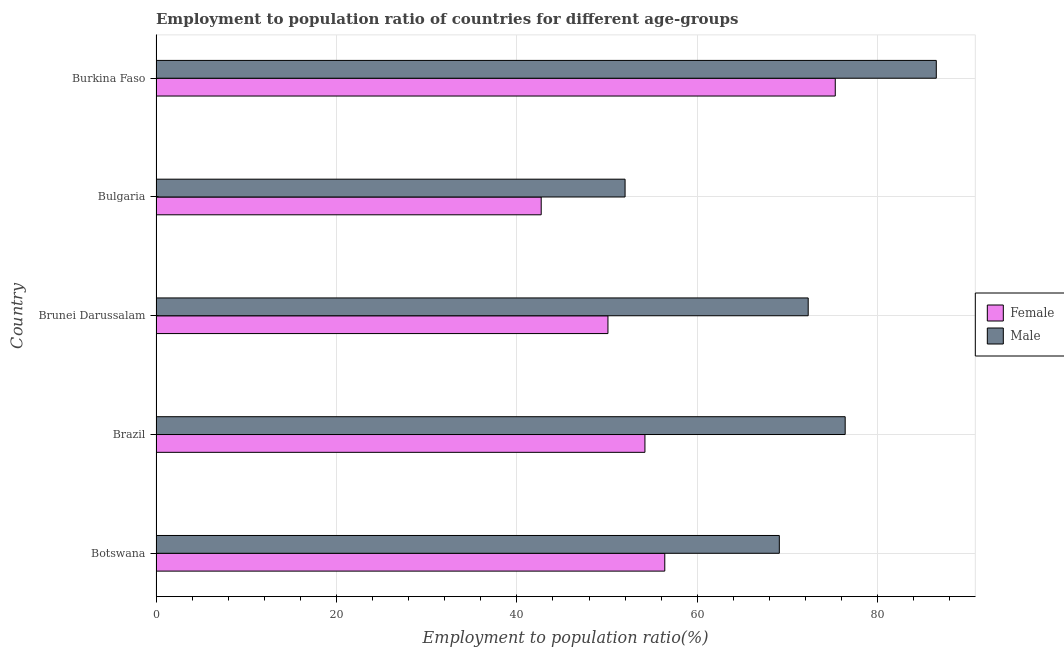How many different coloured bars are there?
Offer a terse response. 2. How many bars are there on the 3rd tick from the bottom?
Offer a very short reply. 2. What is the label of the 5th group of bars from the top?
Make the answer very short. Botswana. What is the employment to population ratio(female) in Bulgaria?
Your response must be concise. 42.7. Across all countries, what is the maximum employment to population ratio(female)?
Make the answer very short. 75.3. In which country was the employment to population ratio(female) maximum?
Offer a terse response. Burkina Faso. In which country was the employment to population ratio(male) minimum?
Provide a succinct answer. Bulgaria. What is the total employment to population ratio(female) in the graph?
Your answer should be compact. 278.7. What is the difference between the employment to population ratio(female) in Brazil and that in Burkina Faso?
Your answer should be compact. -21.1. What is the difference between the employment to population ratio(female) in Brazil and the employment to population ratio(male) in Burkina Faso?
Your answer should be very brief. -32.3. What is the average employment to population ratio(male) per country?
Your answer should be compact. 71.26. What is the difference between the employment to population ratio(male) and employment to population ratio(female) in Burkina Faso?
Your response must be concise. 11.2. What is the ratio of the employment to population ratio(male) in Brazil to that in Burkina Faso?
Your response must be concise. 0.88. Is the employment to population ratio(female) in Botswana less than that in Bulgaria?
Your answer should be compact. No. Is the difference between the employment to population ratio(male) in Botswana and Brazil greater than the difference between the employment to population ratio(female) in Botswana and Brazil?
Provide a short and direct response. No. What is the difference between the highest and the lowest employment to population ratio(male)?
Your response must be concise. 34.5. In how many countries, is the employment to population ratio(male) greater than the average employment to population ratio(male) taken over all countries?
Your response must be concise. 3. What does the 2nd bar from the top in Burkina Faso represents?
Make the answer very short. Female. What does the 1st bar from the bottom in Brunei Darussalam represents?
Provide a succinct answer. Female. How many bars are there?
Give a very brief answer. 10. How many countries are there in the graph?
Your answer should be very brief. 5. What is the difference between two consecutive major ticks on the X-axis?
Make the answer very short. 20. Are the values on the major ticks of X-axis written in scientific E-notation?
Give a very brief answer. No. Does the graph contain any zero values?
Offer a terse response. No. What is the title of the graph?
Ensure brevity in your answer.  Employment to population ratio of countries for different age-groups. Does "Fraud firms" appear as one of the legend labels in the graph?
Make the answer very short. No. What is the label or title of the X-axis?
Keep it short and to the point. Employment to population ratio(%). What is the label or title of the Y-axis?
Provide a succinct answer. Country. What is the Employment to population ratio(%) in Female in Botswana?
Make the answer very short. 56.4. What is the Employment to population ratio(%) in Male in Botswana?
Give a very brief answer. 69.1. What is the Employment to population ratio(%) of Female in Brazil?
Make the answer very short. 54.2. What is the Employment to population ratio(%) of Male in Brazil?
Your answer should be very brief. 76.4. What is the Employment to population ratio(%) of Female in Brunei Darussalam?
Ensure brevity in your answer.  50.1. What is the Employment to population ratio(%) in Male in Brunei Darussalam?
Ensure brevity in your answer.  72.3. What is the Employment to population ratio(%) of Female in Bulgaria?
Keep it short and to the point. 42.7. What is the Employment to population ratio(%) of Male in Bulgaria?
Offer a terse response. 52. What is the Employment to population ratio(%) in Female in Burkina Faso?
Your answer should be compact. 75.3. What is the Employment to population ratio(%) of Male in Burkina Faso?
Your answer should be very brief. 86.5. Across all countries, what is the maximum Employment to population ratio(%) of Female?
Ensure brevity in your answer.  75.3. Across all countries, what is the maximum Employment to population ratio(%) in Male?
Your response must be concise. 86.5. Across all countries, what is the minimum Employment to population ratio(%) of Female?
Provide a short and direct response. 42.7. What is the total Employment to population ratio(%) in Female in the graph?
Ensure brevity in your answer.  278.7. What is the total Employment to population ratio(%) of Male in the graph?
Ensure brevity in your answer.  356.3. What is the difference between the Employment to population ratio(%) in Male in Botswana and that in Brazil?
Provide a succinct answer. -7.3. What is the difference between the Employment to population ratio(%) of Female in Botswana and that in Brunei Darussalam?
Your response must be concise. 6.3. What is the difference between the Employment to population ratio(%) of Female in Botswana and that in Bulgaria?
Your response must be concise. 13.7. What is the difference between the Employment to population ratio(%) in Female in Botswana and that in Burkina Faso?
Keep it short and to the point. -18.9. What is the difference between the Employment to population ratio(%) in Male in Botswana and that in Burkina Faso?
Offer a very short reply. -17.4. What is the difference between the Employment to population ratio(%) in Female in Brazil and that in Bulgaria?
Provide a short and direct response. 11.5. What is the difference between the Employment to population ratio(%) of Male in Brazil and that in Bulgaria?
Provide a succinct answer. 24.4. What is the difference between the Employment to population ratio(%) of Female in Brazil and that in Burkina Faso?
Ensure brevity in your answer.  -21.1. What is the difference between the Employment to population ratio(%) in Male in Brazil and that in Burkina Faso?
Provide a succinct answer. -10.1. What is the difference between the Employment to population ratio(%) in Male in Brunei Darussalam and that in Bulgaria?
Offer a very short reply. 20.3. What is the difference between the Employment to population ratio(%) of Female in Brunei Darussalam and that in Burkina Faso?
Offer a terse response. -25.2. What is the difference between the Employment to population ratio(%) in Male in Brunei Darussalam and that in Burkina Faso?
Provide a succinct answer. -14.2. What is the difference between the Employment to population ratio(%) of Female in Bulgaria and that in Burkina Faso?
Ensure brevity in your answer.  -32.6. What is the difference between the Employment to population ratio(%) in Male in Bulgaria and that in Burkina Faso?
Offer a very short reply. -34.5. What is the difference between the Employment to population ratio(%) of Female in Botswana and the Employment to population ratio(%) of Male in Brunei Darussalam?
Your response must be concise. -15.9. What is the difference between the Employment to population ratio(%) of Female in Botswana and the Employment to population ratio(%) of Male in Bulgaria?
Ensure brevity in your answer.  4.4. What is the difference between the Employment to population ratio(%) in Female in Botswana and the Employment to population ratio(%) in Male in Burkina Faso?
Your answer should be compact. -30.1. What is the difference between the Employment to population ratio(%) in Female in Brazil and the Employment to population ratio(%) in Male in Brunei Darussalam?
Your answer should be very brief. -18.1. What is the difference between the Employment to population ratio(%) of Female in Brazil and the Employment to population ratio(%) of Male in Bulgaria?
Offer a terse response. 2.2. What is the difference between the Employment to population ratio(%) of Female in Brazil and the Employment to population ratio(%) of Male in Burkina Faso?
Give a very brief answer. -32.3. What is the difference between the Employment to population ratio(%) of Female in Brunei Darussalam and the Employment to population ratio(%) of Male in Bulgaria?
Make the answer very short. -1.9. What is the difference between the Employment to population ratio(%) of Female in Brunei Darussalam and the Employment to population ratio(%) of Male in Burkina Faso?
Your response must be concise. -36.4. What is the difference between the Employment to population ratio(%) in Female in Bulgaria and the Employment to population ratio(%) in Male in Burkina Faso?
Your response must be concise. -43.8. What is the average Employment to population ratio(%) of Female per country?
Keep it short and to the point. 55.74. What is the average Employment to population ratio(%) in Male per country?
Provide a succinct answer. 71.26. What is the difference between the Employment to population ratio(%) of Female and Employment to population ratio(%) of Male in Botswana?
Give a very brief answer. -12.7. What is the difference between the Employment to population ratio(%) of Female and Employment to population ratio(%) of Male in Brazil?
Your answer should be very brief. -22.2. What is the difference between the Employment to population ratio(%) in Female and Employment to population ratio(%) in Male in Brunei Darussalam?
Your answer should be very brief. -22.2. What is the difference between the Employment to population ratio(%) of Female and Employment to population ratio(%) of Male in Burkina Faso?
Your answer should be compact. -11.2. What is the ratio of the Employment to population ratio(%) in Female in Botswana to that in Brazil?
Provide a short and direct response. 1.04. What is the ratio of the Employment to population ratio(%) in Male in Botswana to that in Brazil?
Your answer should be very brief. 0.9. What is the ratio of the Employment to population ratio(%) of Female in Botswana to that in Brunei Darussalam?
Your response must be concise. 1.13. What is the ratio of the Employment to population ratio(%) in Male in Botswana to that in Brunei Darussalam?
Give a very brief answer. 0.96. What is the ratio of the Employment to population ratio(%) in Female in Botswana to that in Bulgaria?
Your answer should be very brief. 1.32. What is the ratio of the Employment to population ratio(%) in Male in Botswana to that in Bulgaria?
Provide a succinct answer. 1.33. What is the ratio of the Employment to population ratio(%) in Female in Botswana to that in Burkina Faso?
Make the answer very short. 0.75. What is the ratio of the Employment to population ratio(%) in Male in Botswana to that in Burkina Faso?
Provide a succinct answer. 0.8. What is the ratio of the Employment to population ratio(%) of Female in Brazil to that in Brunei Darussalam?
Provide a short and direct response. 1.08. What is the ratio of the Employment to population ratio(%) of Male in Brazil to that in Brunei Darussalam?
Provide a succinct answer. 1.06. What is the ratio of the Employment to population ratio(%) of Female in Brazil to that in Bulgaria?
Offer a very short reply. 1.27. What is the ratio of the Employment to population ratio(%) in Male in Brazil to that in Bulgaria?
Keep it short and to the point. 1.47. What is the ratio of the Employment to population ratio(%) of Female in Brazil to that in Burkina Faso?
Give a very brief answer. 0.72. What is the ratio of the Employment to population ratio(%) of Male in Brazil to that in Burkina Faso?
Ensure brevity in your answer.  0.88. What is the ratio of the Employment to population ratio(%) of Female in Brunei Darussalam to that in Bulgaria?
Keep it short and to the point. 1.17. What is the ratio of the Employment to population ratio(%) in Male in Brunei Darussalam to that in Bulgaria?
Your answer should be compact. 1.39. What is the ratio of the Employment to population ratio(%) in Female in Brunei Darussalam to that in Burkina Faso?
Your answer should be compact. 0.67. What is the ratio of the Employment to population ratio(%) in Male in Brunei Darussalam to that in Burkina Faso?
Provide a succinct answer. 0.84. What is the ratio of the Employment to population ratio(%) of Female in Bulgaria to that in Burkina Faso?
Ensure brevity in your answer.  0.57. What is the ratio of the Employment to population ratio(%) of Male in Bulgaria to that in Burkina Faso?
Offer a terse response. 0.6. What is the difference between the highest and the second highest Employment to population ratio(%) of Female?
Make the answer very short. 18.9. What is the difference between the highest and the second highest Employment to population ratio(%) of Male?
Ensure brevity in your answer.  10.1. What is the difference between the highest and the lowest Employment to population ratio(%) in Female?
Make the answer very short. 32.6. What is the difference between the highest and the lowest Employment to population ratio(%) in Male?
Ensure brevity in your answer.  34.5. 